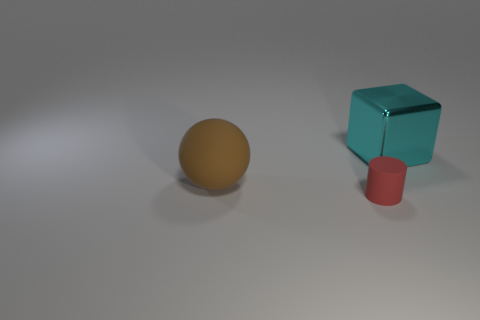Can you describe the composition of the objects in the image? Certainly! The image presents a trio of objects arranged with ample negative space around them. From left to right, there's a sphere, a cube, and a cylinder, creating a harmonious yet varied geometric composition. The placement seems intentional, highlighting both individuality and togetherness in form and color. Does the arrangement have any particular meaning? The arrangement could be seen as a visual exploration of geometric shapes and how they interact with each other and the space around them. It may also be an exercise in perspective, studying how the same light source affects different shapes. While it could simply be an aesthetic choice, some might interpret it as representative of diversity or balance. 